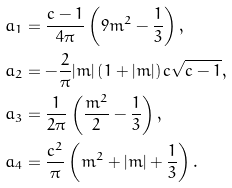<formula> <loc_0><loc_0><loc_500><loc_500>a _ { 1 } & = \frac { c - 1 } { 4 \pi } \left ( 9 m ^ { 2 } - \frac { 1 } { 3 } \right ) , \\ a _ { 2 } & = - \frac { 2 } { \pi } | m | \left ( 1 + | m | \right ) c \sqrt { c - 1 } , \\ a _ { 3 } & = \frac { 1 } { 2 \pi } \left ( \frac { m ^ { 2 } } { 2 } - \frac { 1 } { 3 } \right ) , \\ a _ { 4 } & = \frac { c ^ { 2 } } { \pi } \left ( m ^ { 2 } + | m | + \frac { 1 } { 3 } \right ) .</formula> 